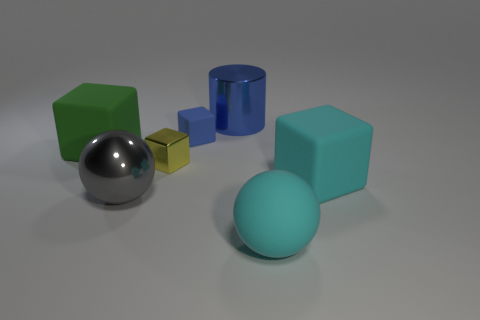Subtract all matte blocks. How many blocks are left? 1 Subtract all cyan balls. How many balls are left? 1 Add 2 large gray matte things. How many objects exist? 9 Subtract all red spheres. How many blue cubes are left? 1 Subtract 0 gray cylinders. How many objects are left? 7 Subtract all spheres. How many objects are left? 5 Subtract all purple spheres. Subtract all purple blocks. How many spheres are left? 2 Subtract all purple matte cubes. Subtract all large metallic cylinders. How many objects are left? 6 Add 6 big blue objects. How many big blue objects are left? 7 Add 2 big cyan matte spheres. How many big cyan matte spheres exist? 3 